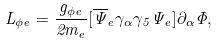Convert formula to latex. <formula><loc_0><loc_0><loc_500><loc_500>L _ { \phi e } = \frac { g _ { \phi e } } { 2 m _ { e } } [ \overline { \Psi } _ { e } \gamma _ { \alpha } \gamma _ { 5 } \Psi _ { e } ] \partial _ { \alpha } \Phi ,</formula> 